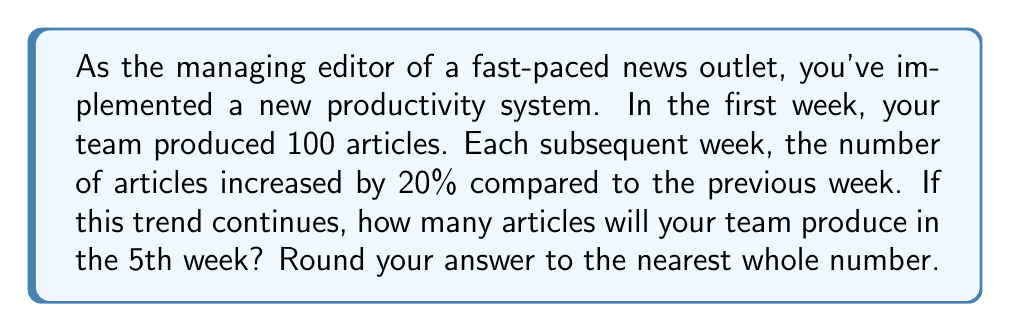Solve this math problem. Let's approach this step-by-step:

1) We're dealing with a geometric progression where the common ratio is 1.20 (a 20% increase is equivalent to multiplying by 1.20).

2) The general formula for the nth term of a geometric progression is:

   $$ a_n = a_1 \cdot r^{n-1} $$

   Where $a_1$ is the first term, $r$ is the common ratio, and $n$ is the term number.

3) In this case:
   $a_1 = 100$ (first week's production)
   $r = 1.20$ (20% increase each week)
   $n = 5$ (we're looking for the 5th week)

4) Let's substitute these values into the formula:

   $$ a_5 = 100 \cdot 1.20^{5-1} = 100 \cdot 1.20^4 $$

5) Now, let's calculate:

   $$ 100 \cdot 1.20^4 = 100 \cdot 2.0736 = 207.36 $$

6) Rounding to the nearest whole number:

   207.36 ≈ 207

Therefore, in the 5th week, the team will produce approximately 207 articles.
Answer: 207 articles 